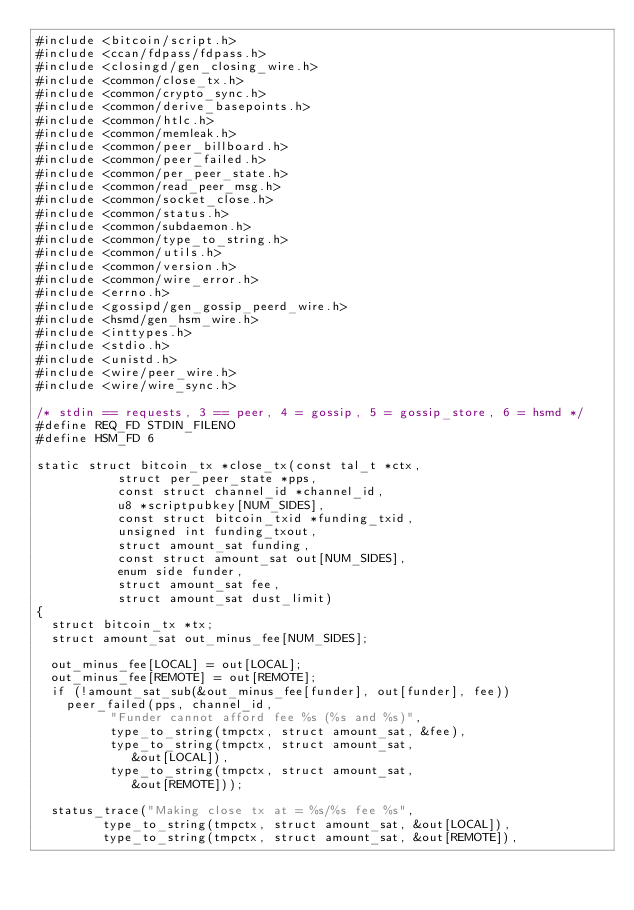<code> <loc_0><loc_0><loc_500><loc_500><_C_>#include <bitcoin/script.h>
#include <ccan/fdpass/fdpass.h>
#include <closingd/gen_closing_wire.h>
#include <common/close_tx.h>
#include <common/crypto_sync.h>
#include <common/derive_basepoints.h>
#include <common/htlc.h>
#include <common/memleak.h>
#include <common/peer_billboard.h>
#include <common/peer_failed.h>
#include <common/per_peer_state.h>
#include <common/read_peer_msg.h>
#include <common/socket_close.h>
#include <common/status.h>
#include <common/subdaemon.h>
#include <common/type_to_string.h>
#include <common/utils.h>
#include <common/version.h>
#include <common/wire_error.h>
#include <errno.h>
#include <gossipd/gen_gossip_peerd_wire.h>
#include <hsmd/gen_hsm_wire.h>
#include <inttypes.h>
#include <stdio.h>
#include <unistd.h>
#include <wire/peer_wire.h>
#include <wire/wire_sync.h>

/* stdin == requests, 3 == peer, 4 = gossip, 5 = gossip_store, 6 = hsmd */
#define REQ_FD STDIN_FILENO
#define HSM_FD 6

static struct bitcoin_tx *close_tx(const tal_t *ctx,
				   struct per_peer_state *pps,
				   const struct channel_id *channel_id,
				   u8 *scriptpubkey[NUM_SIDES],
				   const struct bitcoin_txid *funding_txid,
				   unsigned int funding_txout,
				   struct amount_sat funding,
				   const struct amount_sat out[NUM_SIDES],
				   enum side funder,
				   struct amount_sat fee,
				   struct amount_sat dust_limit)
{
	struct bitcoin_tx *tx;
	struct amount_sat out_minus_fee[NUM_SIDES];

	out_minus_fee[LOCAL] = out[LOCAL];
	out_minus_fee[REMOTE] = out[REMOTE];
	if (!amount_sat_sub(&out_minus_fee[funder], out[funder], fee))
		peer_failed(pps, channel_id,
			    "Funder cannot afford fee %s (%s and %s)",
			    type_to_string(tmpctx, struct amount_sat, &fee),
			    type_to_string(tmpctx, struct amount_sat,
					   &out[LOCAL]),
			    type_to_string(tmpctx, struct amount_sat,
					   &out[REMOTE]));

	status_trace("Making close tx at = %s/%s fee %s",
		     type_to_string(tmpctx, struct amount_sat, &out[LOCAL]),
		     type_to_string(tmpctx, struct amount_sat, &out[REMOTE]),</code> 